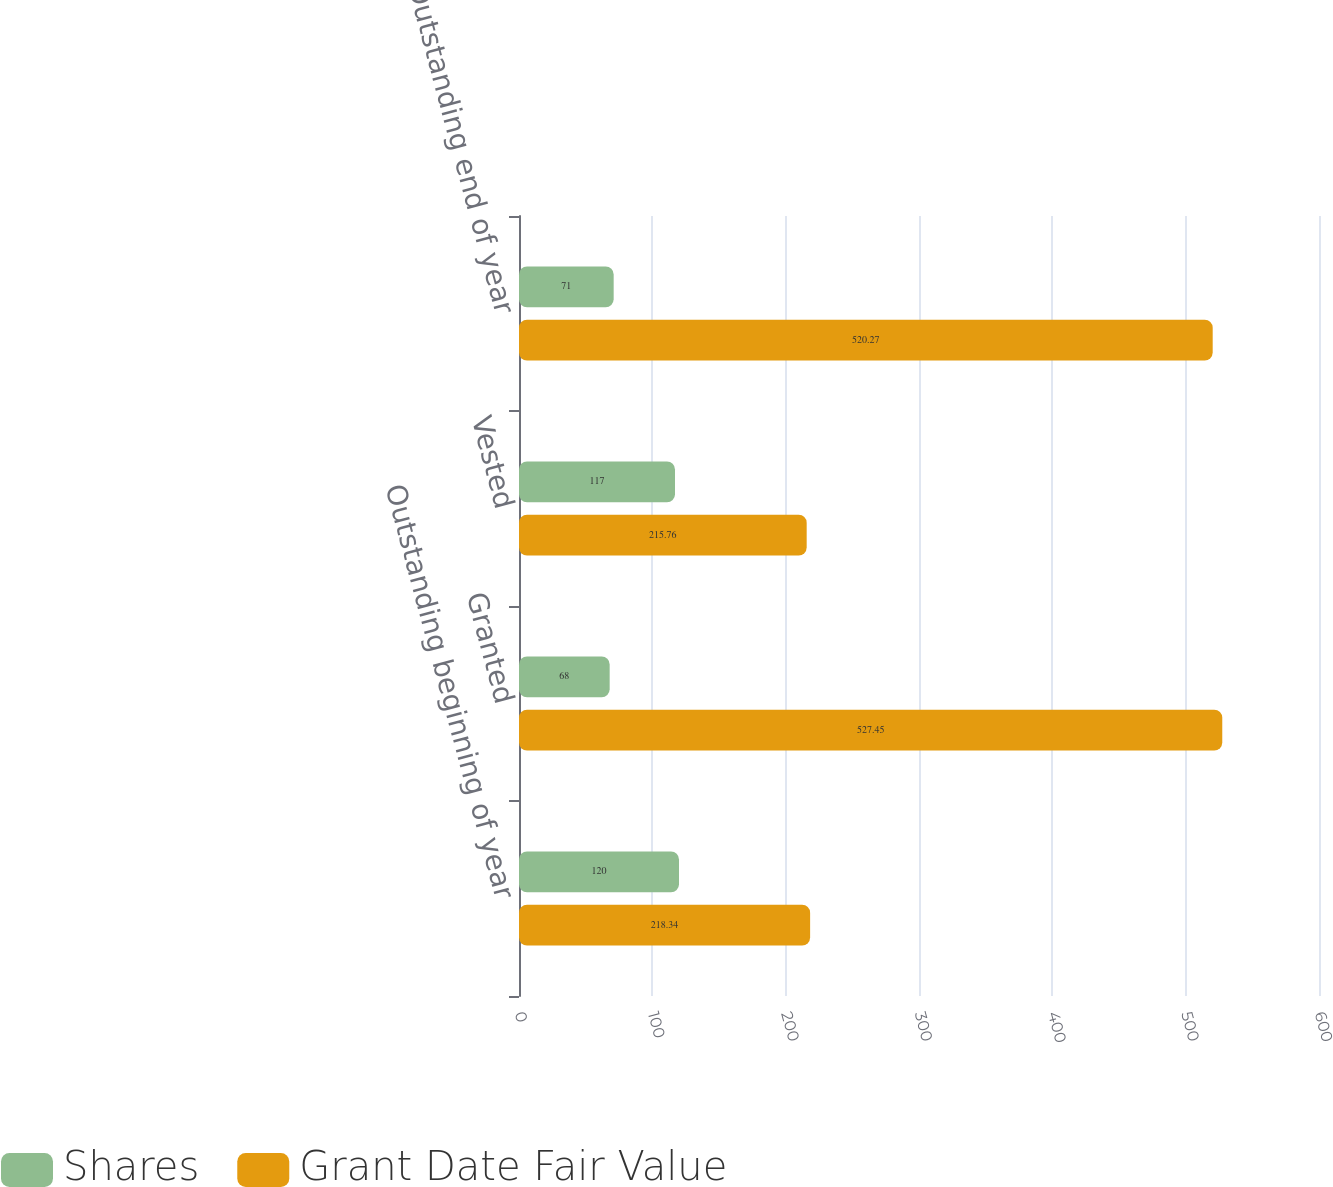Convert chart. <chart><loc_0><loc_0><loc_500><loc_500><stacked_bar_chart><ecel><fcel>Outstanding beginning of year<fcel>Granted<fcel>Vested<fcel>Outstanding end of year<nl><fcel>Shares<fcel>120<fcel>68<fcel>117<fcel>71<nl><fcel>Grant Date Fair Value<fcel>218.34<fcel>527.45<fcel>215.76<fcel>520.27<nl></chart> 